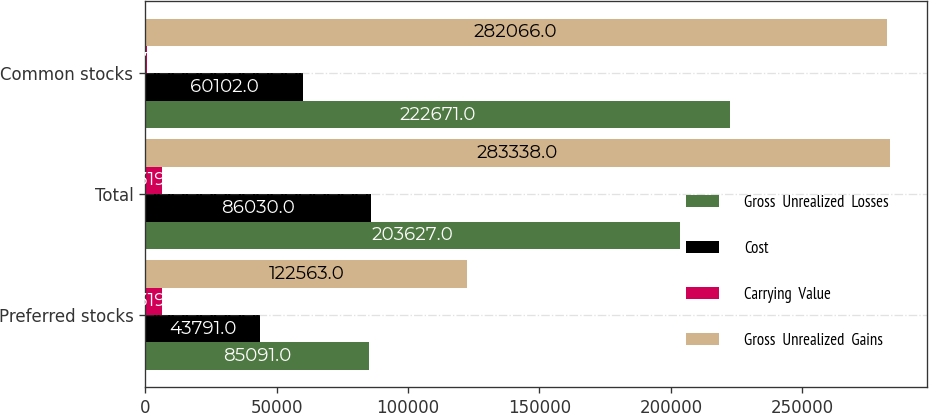Convert chart to OTSL. <chart><loc_0><loc_0><loc_500><loc_500><stacked_bar_chart><ecel><fcel>Preferred stocks<fcel>Total<fcel>Common stocks<nl><fcel>Gross  Unrealized  Losses<fcel>85091<fcel>203627<fcel>222671<nl><fcel>Cost<fcel>43791<fcel>86030<fcel>60102<nl><fcel>Carrying  Value<fcel>6319<fcel>6319<fcel>707<nl><fcel>Gross  Unrealized  Gains<fcel>122563<fcel>283338<fcel>282066<nl></chart> 